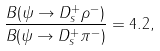Convert formula to latex. <formula><loc_0><loc_0><loc_500><loc_500>\frac { B ( \psi \rightarrow D _ { s } ^ { + } \rho ^ { - } ) } { B ( \psi \rightarrow D _ { s } ^ { + } \pi ^ { - } ) } = 4 . 2 ,</formula> 